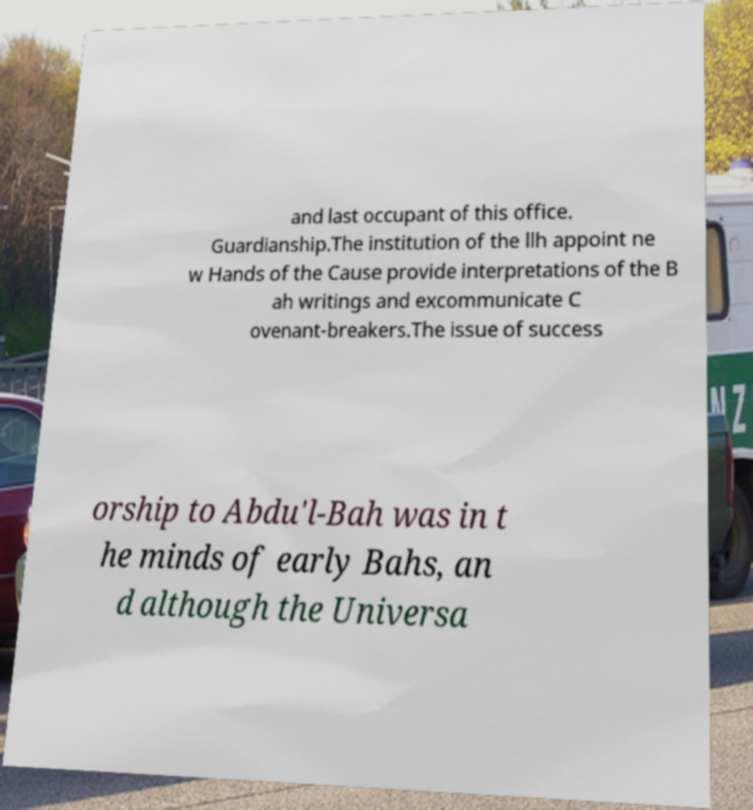For documentation purposes, I need the text within this image transcribed. Could you provide that? and last occupant of this office. Guardianship.The institution of the llh appoint ne w Hands of the Cause provide interpretations of the B ah writings and excommunicate C ovenant-breakers.The issue of success orship to Abdu'l-Bah was in t he minds of early Bahs, an d although the Universa 